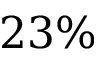<formula> <loc_0><loc_0><loc_500><loc_500>2 3 \%</formula> 